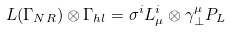Convert formula to latex. <formula><loc_0><loc_0><loc_500><loc_500>L ( \Gamma _ { N R } ) \otimes \Gamma _ { h l } = \sigma ^ { i } L _ { \mu } ^ { i } \otimes \gamma ^ { \mu } _ { \perp } P _ { L }</formula> 